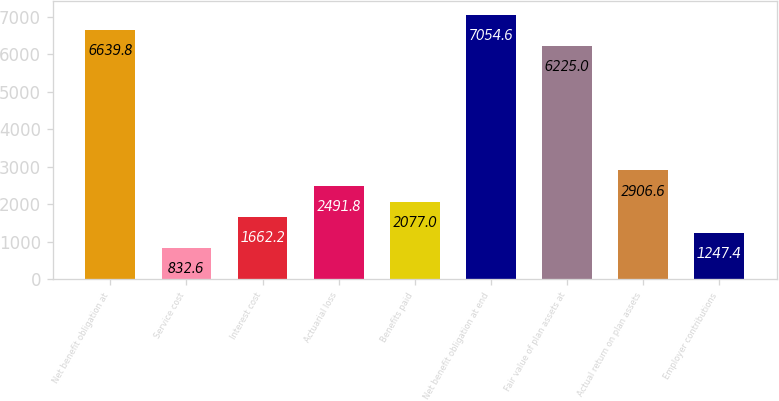<chart> <loc_0><loc_0><loc_500><loc_500><bar_chart><fcel>Net benefit obligation at<fcel>Service cost<fcel>Interest cost<fcel>Actuarial loss<fcel>Benefits paid<fcel>Net benefit obligation at end<fcel>Fair value of plan assets at<fcel>Actual return on plan assets<fcel>Employer contributions<nl><fcel>6639.8<fcel>832.6<fcel>1662.2<fcel>2491.8<fcel>2077<fcel>7054.6<fcel>6225<fcel>2906.6<fcel>1247.4<nl></chart> 